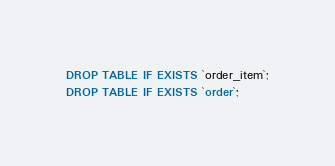<code> <loc_0><loc_0><loc_500><loc_500><_SQL_>DROP TABLE IF EXISTS `order_item`;
DROP TABLE IF EXISTS `order`;</code> 